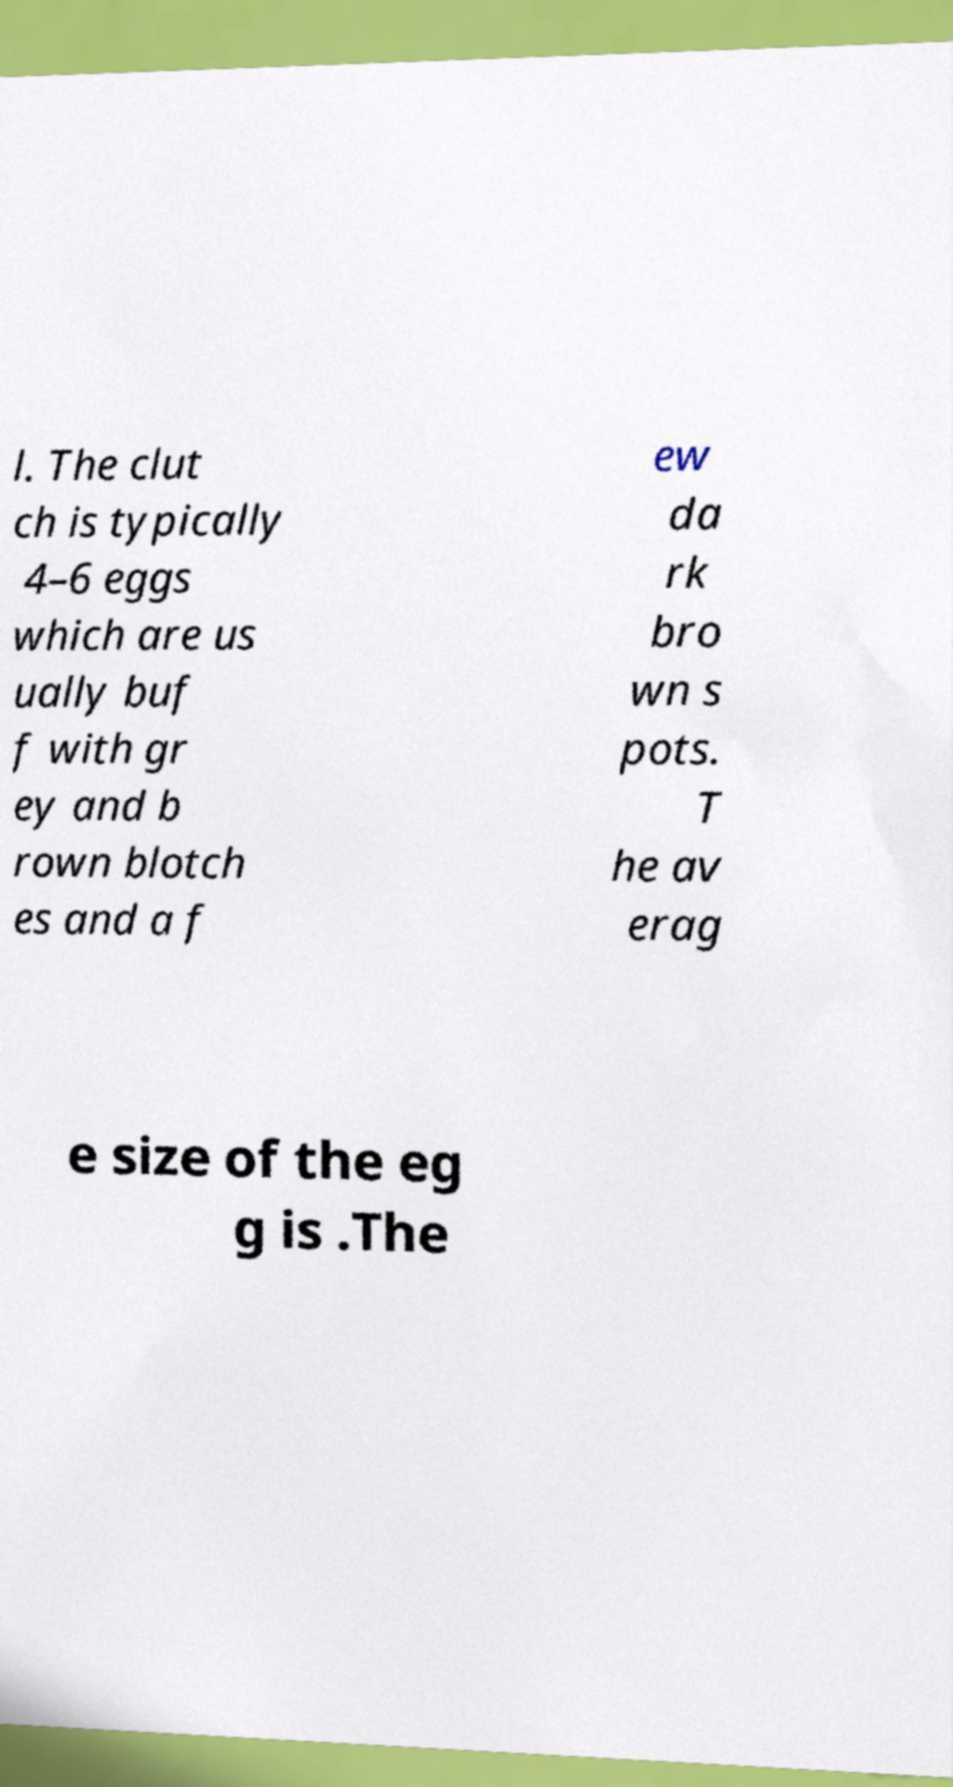There's text embedded in this image that I need extracted. Can you transcribe it verbatim? l. The clut ch is typically 4–6 eggs which are us ually buf f with gr ey and b rown blotch es and a f ew da rk bro wn s pots. T he av erag e size of the eg g is .The 